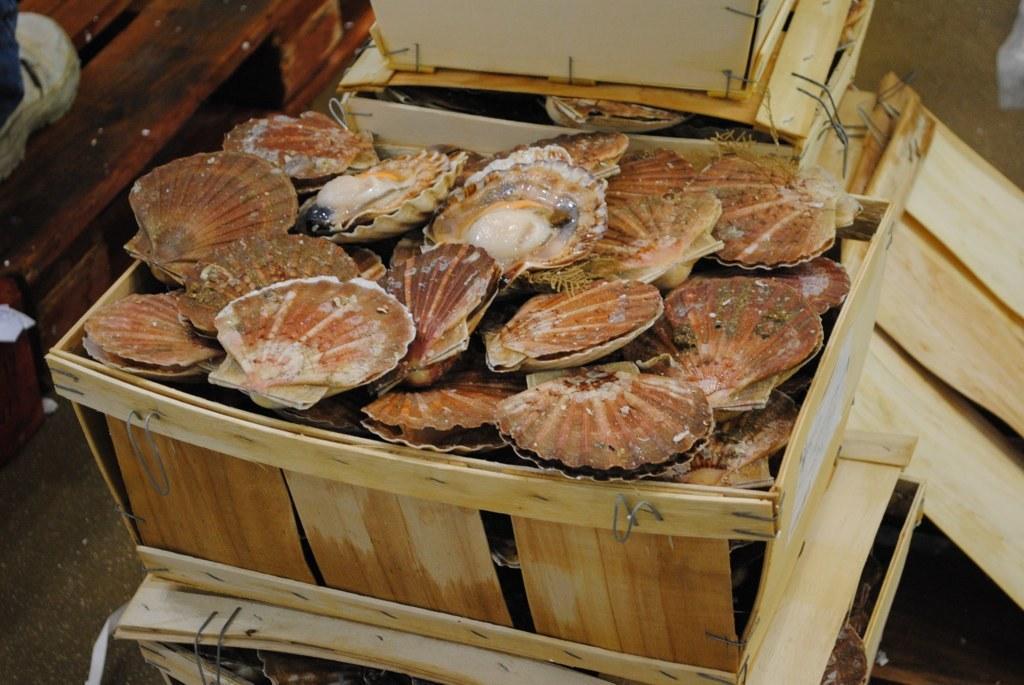Can you describe this image briefly? In this image I can see wooden boxes which are brown and cream in color and in the boxes I can see seashells which are brown, cream and white in color. To the left top of the image I can see a person's leg wearing white colored shoes. 